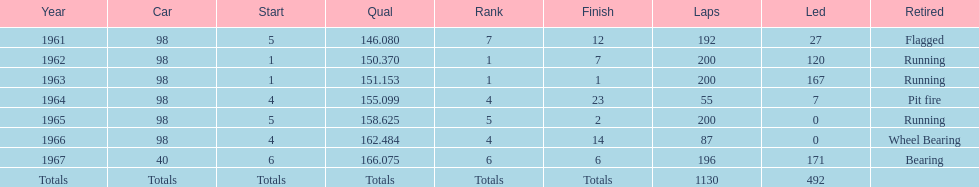Would you mind parsing the complete table? {'header': ['Year', 'Car', 'Start', 'Qual', 'Rank', 'Finish', 'Laps', 'Led', 'Retired'], 'rows': [['1961', '98', '5', '146.080', '7', '12', '192', '27', 'Flagged'], ['1962', '98', '1', '150.370', '1', '7', '200', '120', 'Running'], ['1963', '98', '1', '151.153', '1', '1', '200', '167', 'Running'], ['1964', '98', '4', '155.099', '4', '23', '55', '7', 'Pit fire'], ['1965', '98', '5', '158.625', '5', '2', '200', '0', 'Running'], ['1966', '98', '4', '162.484', '4', '14', '87', '0', 'Wheel Bearing'], ['1967', '40', '6', '166.075', '6', '6', '196', '171', 'Bearing'], ['Totals', 'Totals', 'Totals', 'Totals', 'Totals', 'Totals', '1130', '492', '']]} In what year(s) did parnelli rank 4th or above? 1963, 1965. 